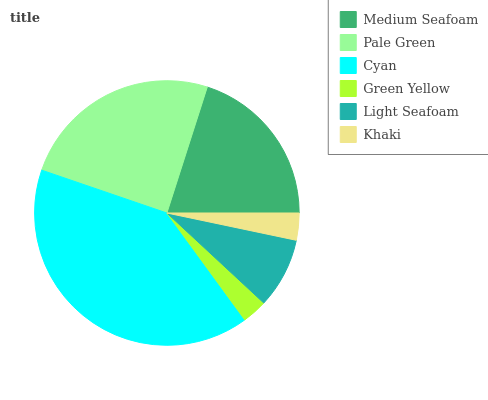Is Green Yellow the minimum?
Answer yes or no. Yes. Is Cyan the maximum?
Answer yes or no. Yes. Is Pale Green the minimum?
Answer yes or no. No. Is Pale Green the maximum?
Answer yes or no. No. Is Pale Green greater than Medium Seafoam?
Answer yes or no. Yes. Is Medium Seafoam less than Pale Green?
Answer yes or no. Yes. Is Medium Seafoam greater than Pale Green?
Answer yes or no. No. Is Pale Green less than Medium Seafoam?
Answer yes or no. No. Is Medium Seafoam the high median?
Answer yes or no. Yes. Is Light Seafoam the low median?
Answer yes or no. Yes. Is Light Seafoam the high median?
Answer yes or no. No. Is Cyan the low median?
Answer yes or no. No. 